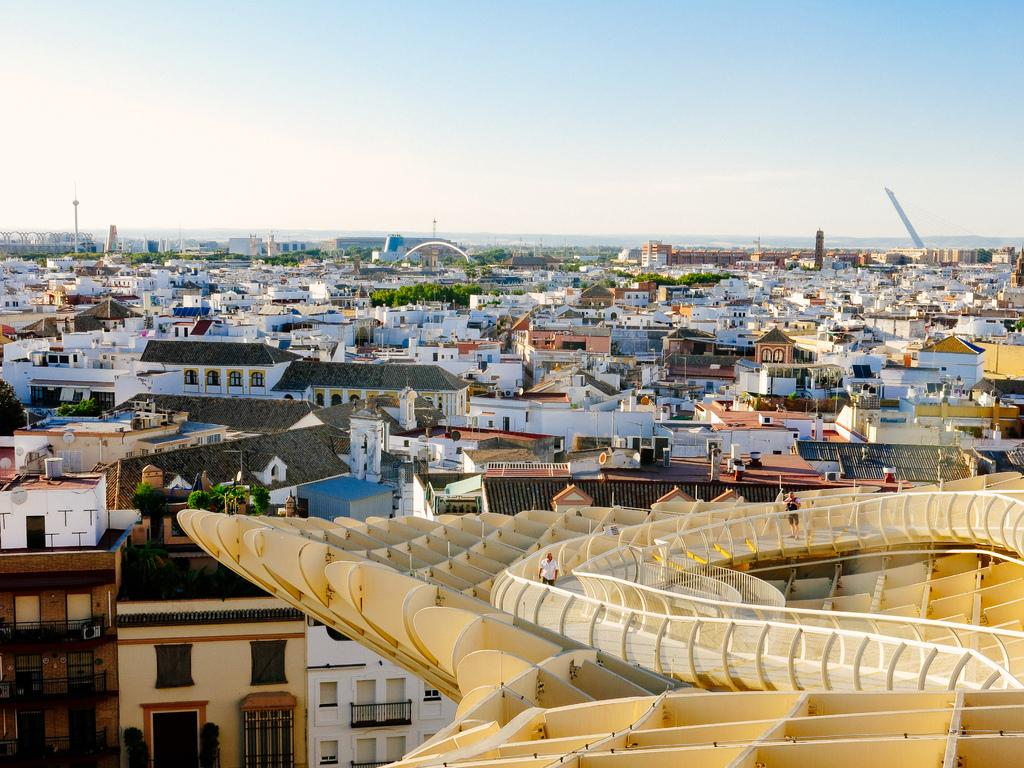What is located in the right corner of the image? There is an object in the right corner of the image. What are the two persons doing on the object? Two persons are standing on the object. What can be seen in the distance in the image? There are buildings and trees in the background of the image. What type of lift is being used by the persons in the image? There is no lift present in the image; the two persons are standing on an object. What stage of development is the tub in the image? There is no tub present in the image. 